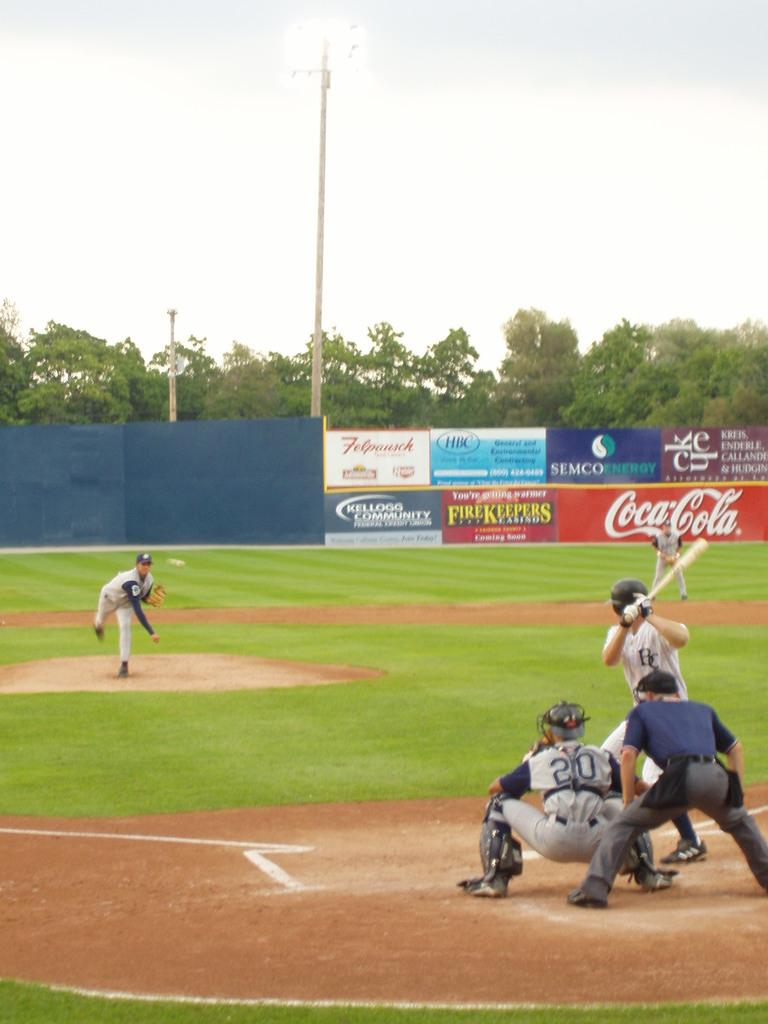<image>
Write a terse but informative summary of the picture. Coca-Cola is one of many companies with banners on the ball of a baseball field where a game in underway. 